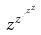<formula> <loc_0><loc_0><loc_500><loc_500>z ^ { z ^ { \cdot ^ { \cdot ^ { z ^ { z } } } } }</formula> 